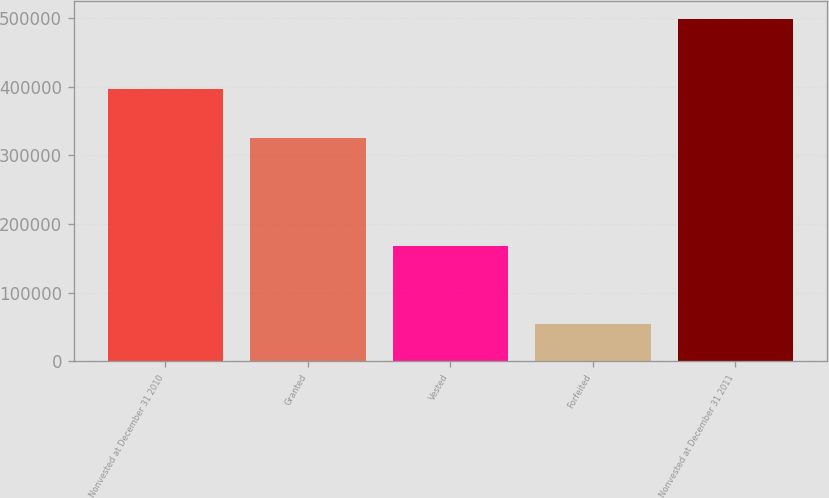<chart> <loc_0><loc_0><loc_500><loc_500><bar_chart><fcel>Nonvested at December 31 2010<fcel>Granted<fcel>Vested<fcel>Forfeited<fcel>Nonvested at December 31 2011<nl><fcel>395950<fcel>325447<fcel>167414<fcel>54864<fcel>499119<nl></chart> 